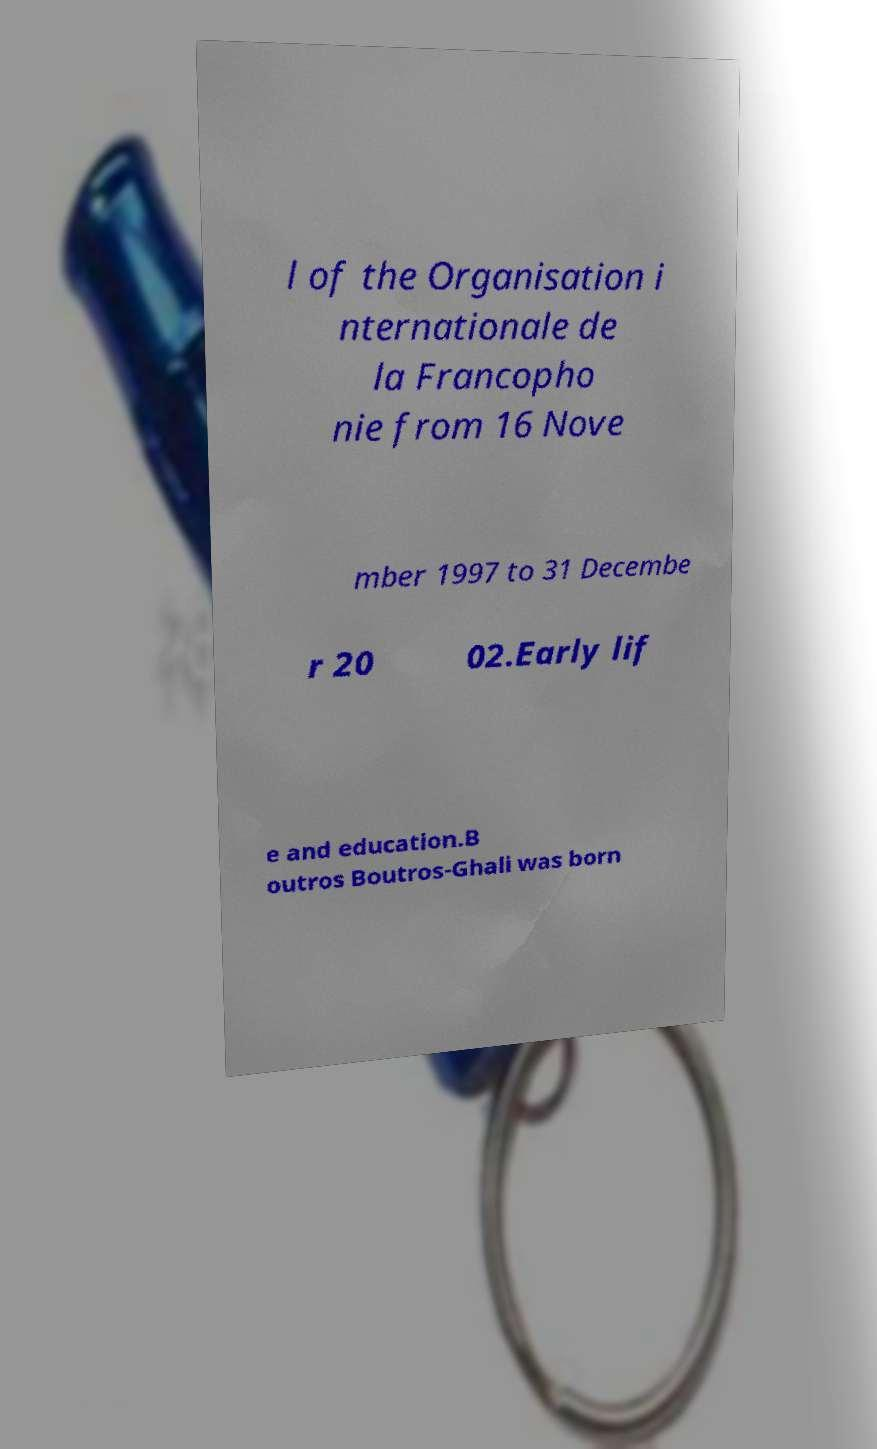Can you read and provide the text displayed in the image?This photo seems to have some interesting text. Can you extract and type it out for me? l of the Organisation i nternationale de la Francopho nie from 16 Nove mber 1997 to 31 Decembe r 20 02.Early lif e and education.B outros Boutros-Ghali was born 